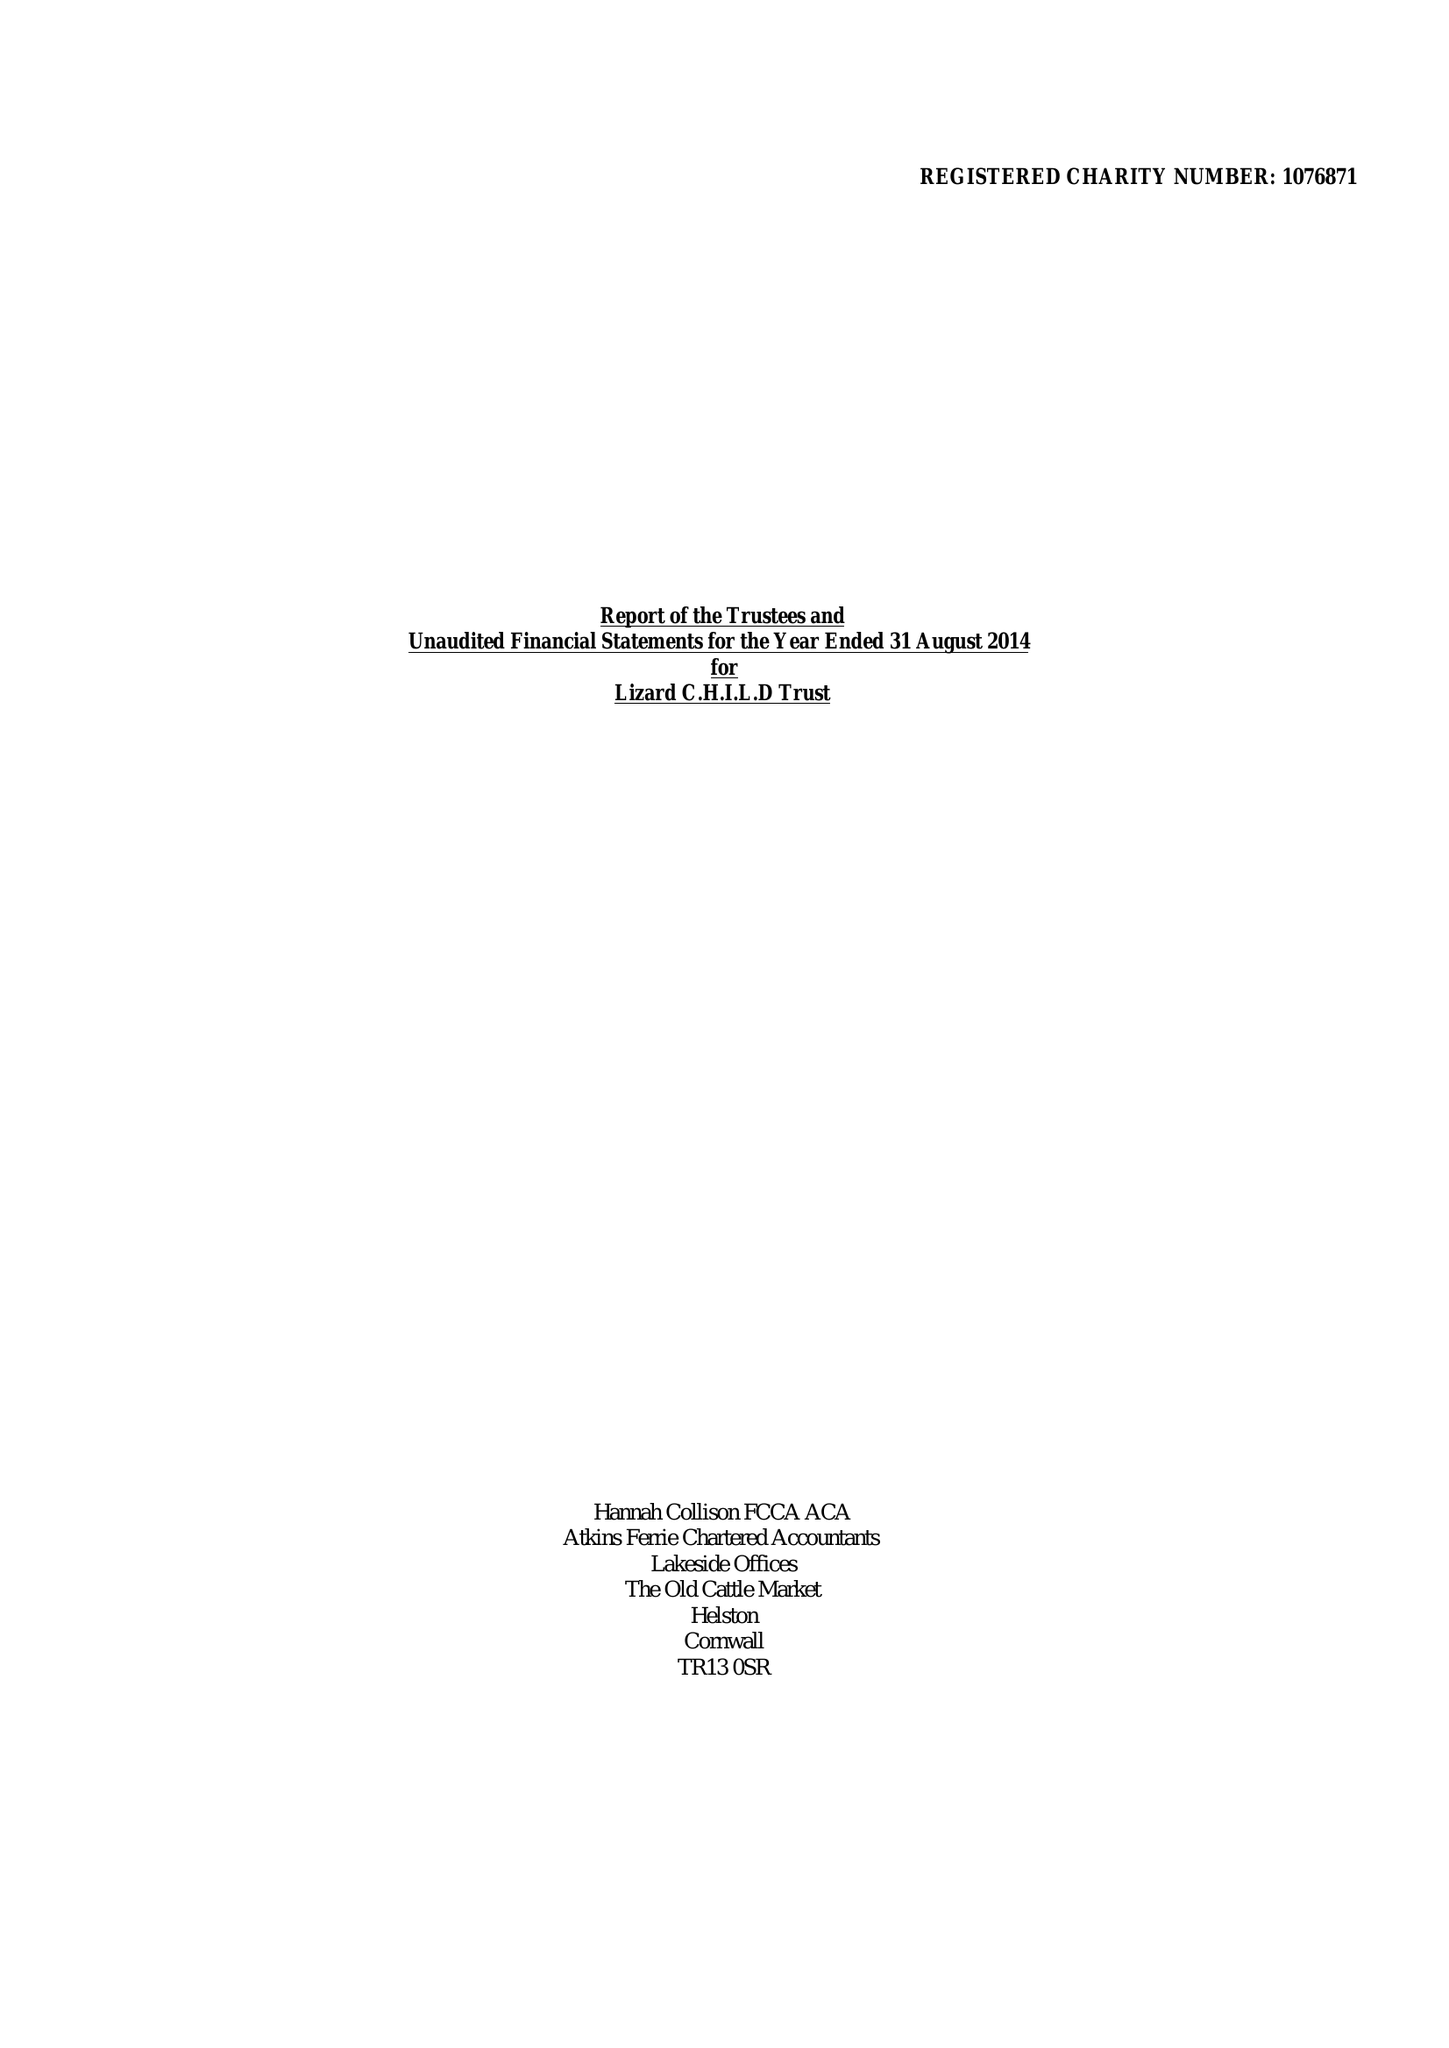What is the value for the report_date?
Answer the question using a single word or phrase. 2014-08-31 